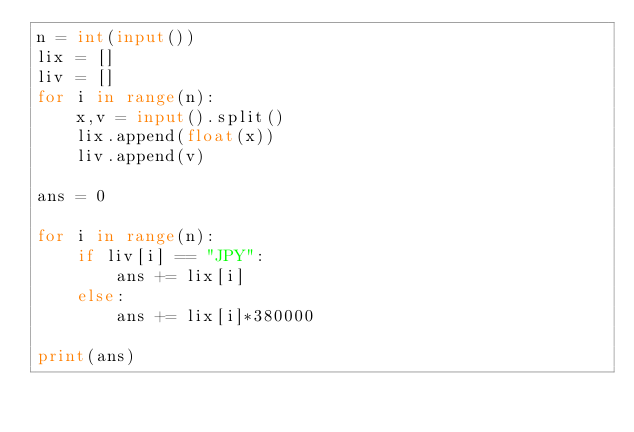<code> <loc_0><loc_0><loc_500><loc_500><_Python_>n = int(input())
lix = []
liv = []
for i in range(n):
    x,v = input().split()
    lix.append(float(x))
    liv.append(v)

ans = 0

for i in range(n):
    if liv[i] == "JPY":
        ans += lix[i]
    else:
        ans += lix[i]*380000

print(ans)</code> 